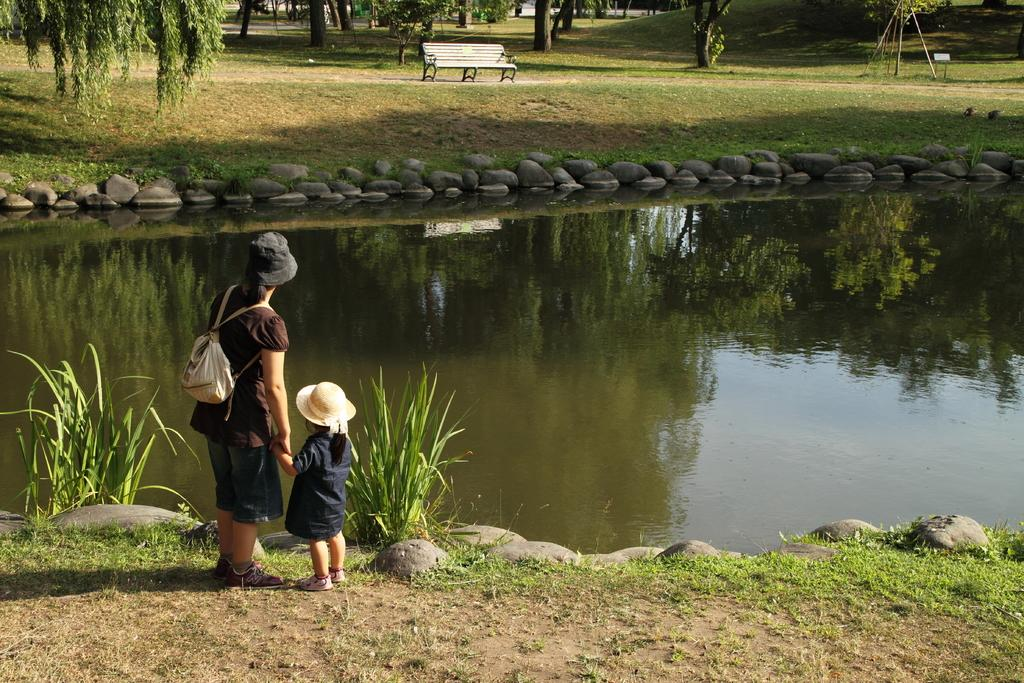Who is present in the image? There is a woman in the image. What is the woman wearing? The woman is wearing a bag. What is the woman doing with the girl? The woman is holding the hand of a girl. What can be seen in the background of the image? There is water visible in the image, as well as trees and a bench in the distance. What type of butter is being spread on the bread in the image? There is no bread or butter present in the image; it features a woman holding the hand of a girl near water and trees. 